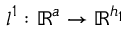Convert formula to latex. <formula><loc_0><loc_0><loc_500><loc_500>l ^ { 1 } \colon \mathbb { R } ^ { a } \rightarrow \mathbb { R } ^ { h _ { 1 } }</formula> 